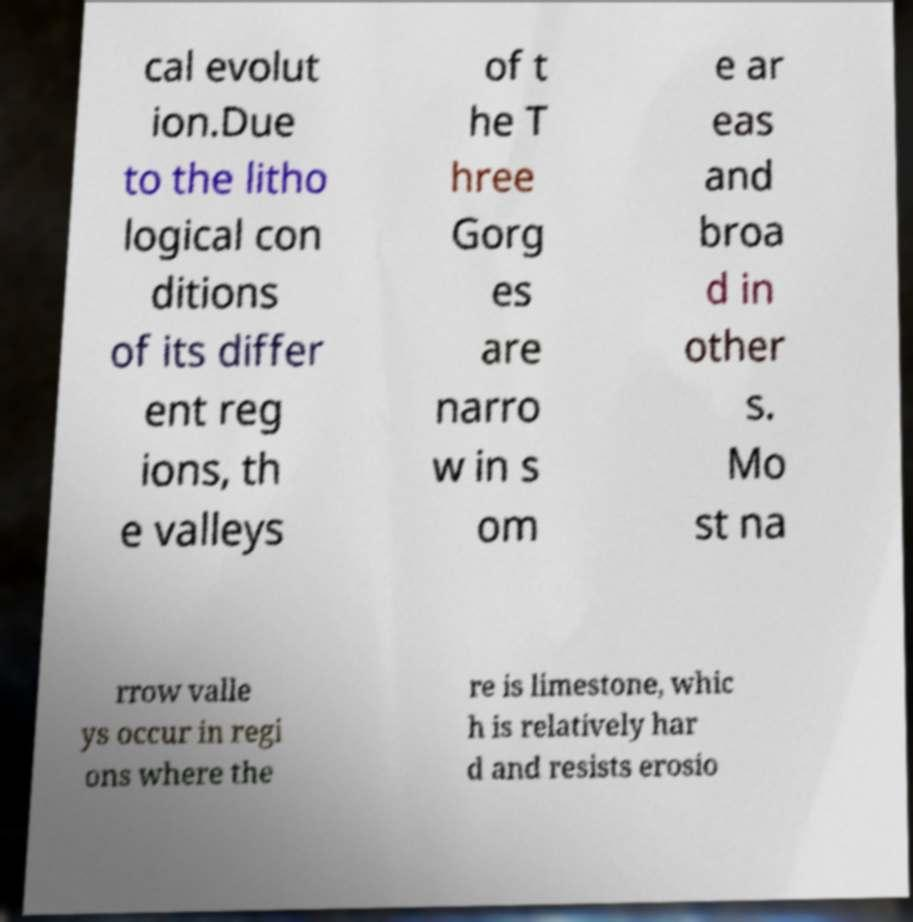Can you accurately transcribe the text from the provided image for me? cal evolut ion.Due to the litho logical con ditions of its differ ent reg ions, th e valleys of t he T hree Gorg es are narro w in s om e ar eas and broa d in other s. Mo st na rrow valle ys occur in regi ons where the re is limestone, whic h is relatively har d and resists erosio 